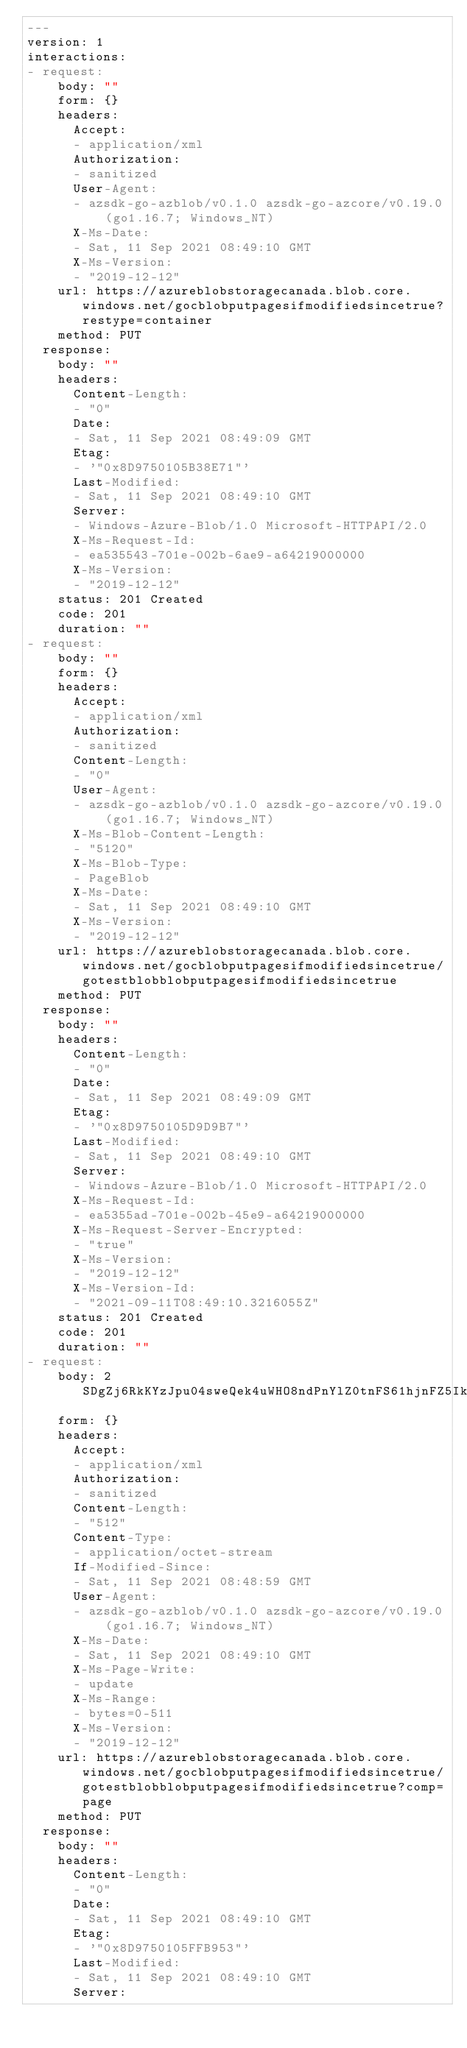Convert code to text. <code><loc_0><loc_0><loc_500><loc_500><_YAML_>---
version: 1
interactions:
- request:
    body: ""
    form: {}
    headers:
      Accept:
      - application/xml
      Authorization:
      - sanitized
      User-Agent:
      - azsdk-go-azblob/v0.1.0 azsdk-go-azcore/v0.19.0 (go1.16.7; Windows_NT)
      X-Ms-Date:
      - Sat, 11 Sep 2021 08:49:10 GMT
      X-Ms-Version:
      - "2019-12-12"
    url: https://azureblobstoragecanada.blob.core.windows.net/gocblobputpagesifmodifiedsincetrue?restype=container
    method: PUT
  response:
    body: ""
    headers:
      Content-Length:
      - "0"
      Date:
      - Sat, 11 Sep 2021 08:49:09 GMT
      Etag:
      - '"0x8D9750105B38E71"'
      Last-Modified:
      - Sat, 11 Sep 2021 08:49:10 GMT
      Server:
      - Windows-Azure-Blob/1.0 Microsoft-HTTPAPI/2.0
      X-Ms-Request-Id:
      - ea535543-701e-002b-6ae9-a64219000000
      X-Ms-Version:
      - "2019-12-12"
    status: 201 Created
    code: 201
    duration: ""
- request:
    body: ""
    form: {}
    headers:
      Accept:
      - application/xml
      Authorization:
      - sanitized
      Content-Length:
      - "0"
      User-Agent:
      - azsdk-go-azblob/v0.1.0 azsdk-go-azcore/v0.19.0 (go1.16.7; Windows_NT)
      X-Ms-Blob-Content-Length:
      - "5120"
      X-Ms-Blob-Type:
      - PageBlob
      X-Ms-Date:
      - Sat, 11 Sep 2021 08:49:10 GMT
      X-Ms-Version:
      - "2019-12-12"
    url: https://azureblobstoragecanada.blob.core.windows.net/gocblobputpagesifmodifiedsincetrue/gotestblobblobputpagesifmodifiedsincetrue
    method: PUT
  response:
    body: ""
    headers:
      Content-Length:
      - "0"
      Date:
      - Sat, 11 Sep 2021 08:49:09 GMT
      Etag:
      - '"0x8D9750105D9D9B7"'
      Last-Modified:
      - Sat, 11 Sep 2021 08:49:10 GMT
      Server:
      - Windows-Azure-Blob/1.0 Microsoft-HTTPAPI/2.0
      X-Ms-Request-Id:
      - ea5355ad-701e-002b-45e9-a64219000000
      X-Ms-Request-Server-Encrypted:
      - "true"
      X-Ms-Version:
      - "2019-12-12"
      X-Ms-Version-Id:
      - "2021-09-11T08:49:10.3216055Z"
    status: 201 Created
    code: 201
    duration: ""
- request:
    body: 2SDgZj6RkKYzJpu04sweQek4uWHO8ndPnYlZ0tnFS61hjnFZ5IkvIGGY44eKABov2SDgZj6RkKYzJpu04sweQek4uWHO8ndPnYlZ0tnFS61hjnFZ5IkvIGGY44eKABov2SDgZj6RkKYzJpu04sweQek4uWHO8ndPnYlZ0tnFS61hjnFZ5IkvIGGY44eKABov2SDgZj6RkKYzJpu04sweQek4uWHO8ndPnYlZ0tnFS61hjnFZ5IkvIGGY44eKABov2SDgZj6RkKYzJpu04sweQek4uWHO8ndPnYlZ0tnFS61hjnFZ5IkvIGGY44eKABov2SDgZj6RkKYzJpu04sweQek4uWHO8ndPnYlZ0tnFS61hjnFZ5IkvIGGY44eKABov2SDgZj6RkKYzJpu04sweQek4uWHO8ndPnYlZ0tnFS61hjnFZ5IkvIGGY44eKABov2SDgZj6RkKYzJpu04sweQek4uWHO8ndPnYlZ0tnFS61hjnFZ5IkvIGGY44eKABov
    form: {}
    headers:
      Accept:
      - application/xml
      Authorization:
      - sanitized
      Content-Length:
      - "512"
      Content-Type:
      - application/octet-stream
      If-Modified-Since:
      - Sat, 11 Sep 2021 08:48:59 GMT
      User-Agent:
      - azsdk-go-azblob/v0.1.0 azsdk-go-azcore/v0.19.0 (go1.16.7; Windows_NT)
      X-Ms-Date:
      - Sat, 11 Sep 2021 08:49:10 GMT
      X-Ms-Page-Write:
      - update
      X-Ms-Range:
      - bytes=0-511
      X-Ms-Version:
      - "2019-12-12"
    url: https://azureblobstoragecanada.blob.core.windows.net/gocblobputpagesifmodifiedsincetrue/gotestblobblobputpagesifmodifiedsincetrue?comp=page
    method: PUT
  response:
    body: ""
    headers:
      Content-Length:
      - "0"
      Date:
      - Sat, 11 Sep 2021 08:49:10 GMT
      Etag:
      - '"0x8D9750105FFB953"'
      Last-Modified:
      - Sat, 11 Sep 2021 08:49:10 GMT
      Server:</code> 